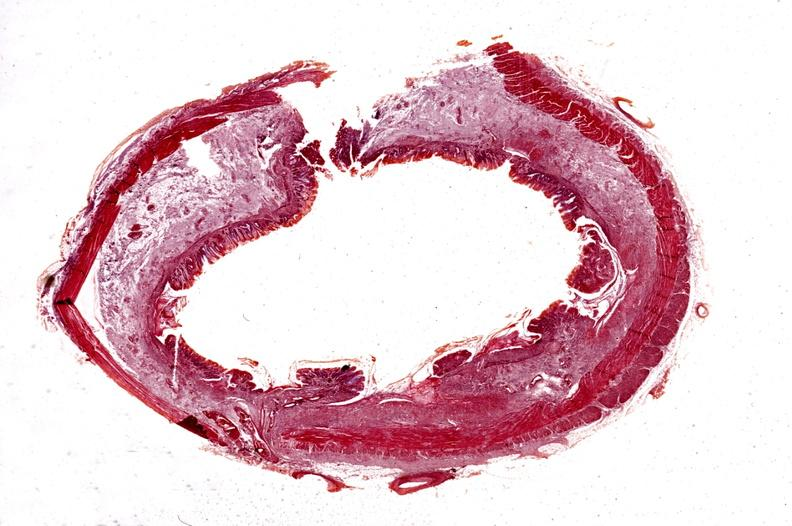does this image show colon, chronic ulcerative colitis?
Answer the question using a single word or phrase. Yes 